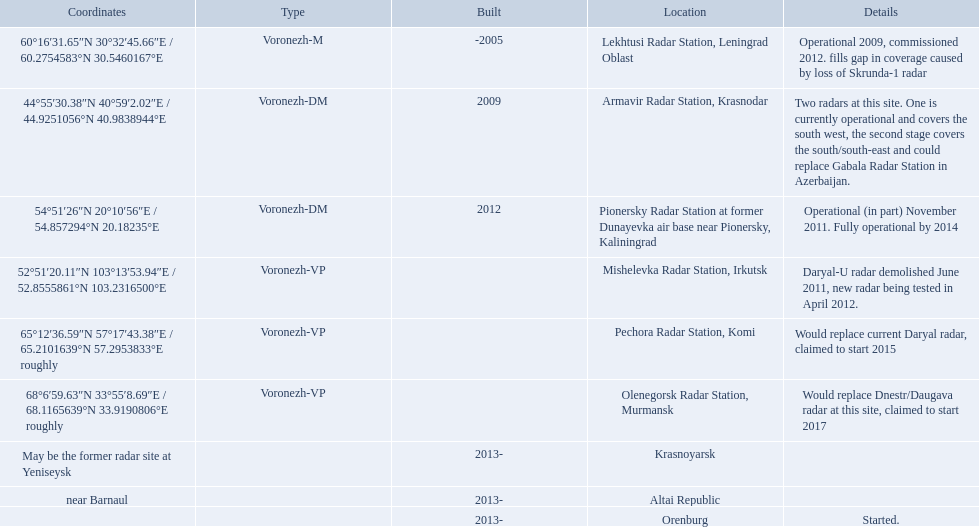Which voronezh radar has already started? Orenburg. Which radar would replace dnestr/daugava? Olenegorsk Radar Station, Murmansk. Which radar started in 2015? Pechora Radar Station, Komi. What are the list of radar locations? Lekhtusi Radar Station, Leningrad Oblast, Armavir Radar Station, Krasnodar, Pionersky Radar Station at former Dunayevka air base near Pionersky, Kaliningrad, Mishelevka Radar Station, Irkutsk, Pechora Radar Station, Komi, Olenegorsk Radar Station, Murmansk, Krasnoyarsk, Altai Republic, Orenburg. Which of these are claimed to start in 2015? Pechora Radar Station, Komi. 